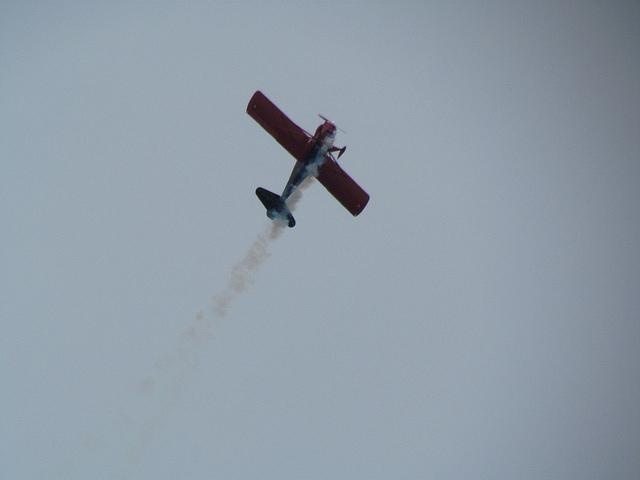What is the person riding on?
Be succinct. Plane. Does the plane have a propeller?
Concise answer only. Yes. How many engines does the plane have?
Write a very short answer. 1. Is this a drawling or a photograph?
Short answer required. Photograph. What is trailing from the plane?
Concise answer only. Smoke. What is pictured in the air?
Give a very brief answer. Plane. What is the color of the sky?
Concise answer only. Blue. Is the plane red?
Quick response, please. Yes. How many jets are there?
Keep it brief. 0. Is there clouds in the sky?
Answer briefly. No. Which parts of the plane burn fire?
Answer briefly. Engine. How big is this plane?
Short answer required. Small. 